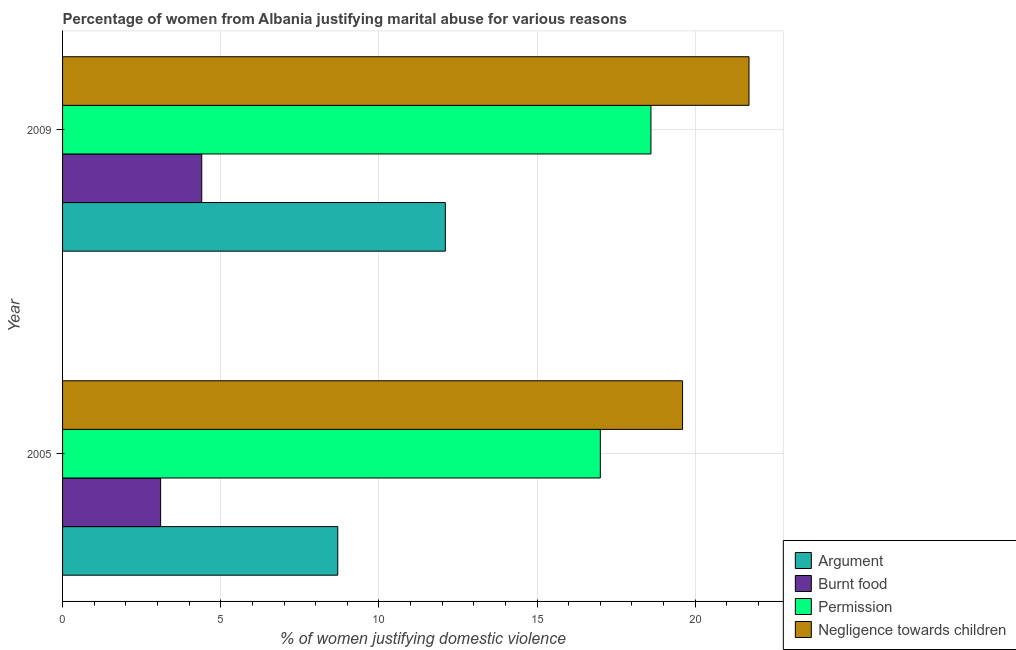How many groups of bars are there?
Provide a succinct answer. 2. How many bars are there on the 1st tick from the bottom?
Make the answer very short. 4. What is the label of the 2nd group of bars from the top?
Your response must be concise. 2005. In how many cases, is the number of bars for a given year not equal to the number of legend labels?
Offer a terse response. 0. What is the percentage of women justifying abuse for burning food in 2005?
Ensure brevity in your answer.  3.1. In which year was the percentage of women justifying abuse for showing negligence towards children maximum?
Your answer should be compact. 2009. In which year was the percentage of women justifying abuse for going without permission minimum?
Your answer should be compact. 2005. What is the total percentage of women justifying abuse for going without permission in the graph?
Ensure brevity in your answer.  35.6. What is the difference between the percentage of women justifying abuse for burning food in 2009 and the percentage of women justifying abuse in the case of an argument in 2005?
Your answer should be compact. -4.3. What is the average percentage of women justifying abuse for burning food per year?
Your answer should be compact. 3.75. In the year 2005, what is the difference between the percentage of women justifying abuse for burning food and percentage of women justifying abuse for showing negligence towards children?
Ensure brevity in your answer.  -16.5. In how many years, is the percentage of women justifying abuse for going without permission greater than 14 %?
Your answer should be very brief. 2. What is the ratio of the percentage of women justifying abuse for showing negligence towards children in 2005 to that in 2009?
Provide a short and direct response. 0.9. Is the percentage of women justifying abuse for showing negligence towards children in 2005 less than that in 2009?
Ensure brevity in your answer.  Yes. Is the difference between the percentage of women justifying abuse for burning food in 2005 and 2009 greater than the difference between the percentage of women justifying abuse for going without permission in 2005 and 2009?
Provide a short and direct response. Yes. In how many years, is the percentage of women justifying abuse in the case of an argument greater than the average percentage of women justifying abuse in the case of an argument taken over all years?
Ensure brevity in your answer.  1. What does the 1st bar from the top in 2005 represents?
Offer a very short reply. Negligence towards children. What does the 2nd bar from the bottom in 2005 represents?
Your answer should be very brief. Burnt food. Is it the case that in every year, the sum of the percentage of women justifying abuse in the case of an argument and percentage of women justifying abuse for burning food is greater than the percentage of women justifying abuse for going without permission?
Make the answer very short. No. Does the graph contain any zero values?
Ensure brevity in your answer.  No. Does the graph contain grids?
Provide a succinct answer. Yes. Where does the legend appear in the graph?
Ensure brevity in your answer.  Bottom right. How many legend labels are there?
Make the answer very short. 4. How are the legend labels stacked?
Your response must be concise. Vertical. What is the title of the graph?
Your answer should be very brief. Percentage of women from Albania justifying marital abuse for various reasons. Does "HFC gas" appear as one of the legend labels in the graph?
Provide a short and direct response. No. What is the label or title of the X-axis?
Offer a terse response. % of women justifying domestic violence. What is the label or title of the Y-axis?
Offer a terse response. Year. What is the % of women justifying domestic violence in Argument in 2005?
Keep it short and to the point. 8.7. What is the % of women justifying domestic violence in Burnt food in 2005?
Your answer should be compact. 3.1. What is the % of women justifying domestic violence of Negligence towards children in 2005?
Make the answer very short. 19.6. What is the % of women justifying domestic violence in Permission in 2009?
Offer a very short reply. 18.6. What is the % of women justifying domestic violence of Negligence towards children in 2009?
Ensure brevity in your answer.  21.7. Across all years, what is the maximum % of women justifying domestic violence of Burnt food?
Offer a terse response. 4.4. Across all years, what is the maximum % of women justifying domestic violence in Permission?
Keep it short and to the point. 18.6. Across all years, what is the maximum % of women justifying domestic violence of Negligence towards children?
Your response must be concise. 21.7. Across all years, what is the minimum % of women justifying domestic violence of Negligence towards children?
Make the answer very short. 19.6. What is the total % of women justifying domestic violence of Argument in the graph?
Keep it short and to the point. 20.8. What is the total % of women justifying domestic violence of Burnt food in the graph?
Provide a succinct answer. 7.5. What is the total % of women justifying domestic violence in Permission in the graph?
Give a very brief answer. 35.6. What is the total % of women justifying domestic violence of Negligence towards children in the graph?
Make the answer very short. 41.3. What is the difference between the % of women justifying domestic violence in Permission in 2005 and that in 2009?
Your response must be concise. -1.6. What is the difference between the % of women justifying domestic violence of Negligence towards children in 2005 and that in 2009?
Give a very brief answer. -2.1. What is the difference between the % of women justifying domestic violence in Argument in 2005 and the % of women justifying domestic violence in Burnt food in 2009?
Ensure brevity in your answer.  4.3. What is the difference between the % of women justifying domestic violence of Argument in 2005 and the % of women justifying domestic violence of Permission in 2009?
Provide a short and direct response. -9.9. What is the difference between the % of women justifying domestic violence of Burnt food in 2005 and the % of women justifying domestic violence of Permission in 2009?
Give a very brief answer. -15.5. What is the difference between the % of women justifying domestic violence of Burnt food in 2005 and the % of women justifying domestic violence of Negligence towards children in 2009?
Your answer should be very brief. -18.6. What is the difference between the % of women justifying domestic violence in Permission in 2005 and the % of women justifying domestic violence in Negligence towards children in 2009?
Offer a terse response. -4.7. What is the average % of women justifying domestic violence of Argument per year?
Provide a short and direct response. 10.4. What is the average % of women justifying domestic violence of Burnt food per year?
Offer a very short reply. 3.75. What is the average % of women justifying domestic violence in Negligence towards children per year?
Your answer should be compact. 20.65. In the year 2005, what is the difference between the % of women justifying domestic violence in Argument and % of women justifying domestic violence in Burnt food?
Make the answer very short. 5.6. In the year 2005, what is the difference between the % of women justifying domestic violence of Burnt food and % of women justifying domestic violence of Permission?
Ensure brevity in your answer.  -13.9. In the year 2005, what is the difference between the % of women justifying domestic violence in Burnt food and % of women justifying domestic violence in Negligence towards children?
Offer a very short reply. -16.5. In the year 2009, what is the difference between the % of women justifying domestic violence in Burnt food and % of women justifying domestic violence in Negligence towards children?
Give a very brief answer. -17.3. In the year 2009, what is the difference between the % of women justifying domestic violence of Permission and % of women justifying domestic violence of Negligence towards children?
Provide a succinct answer. -3.1. What is the ratio of the % of women justifying domestic violence of Argument in 2005 to that in 2009?
Your response must be concise. 0.72. What is the ratio of the % of women justifying domestic violence of Burnt food in 2005 to that in 2009?
Ensure brevity in your answer.  0.7. What is the ratio of the % of women justifying domestic violence of Permission in 2005 to that in 2009?
Your response must be concise. 0.91. What is the ratio of the % of women justifying domestic violence of Negligence towards children in 2005 to that in 2009?
Offer a terse response. 0.9. What is the difference between the highest and the second highest % of women justifying domestic violence of Argument?
Ensure brevity in your answer.  3.4. What is the difference between the highest and the second highest % of women justifying domestic violence in Burnt food?
Your response must be concise. 1.3. What is the difference between the highest and the second highest % of women justifying domestic violence of Negligence towards children?
Your answer should be compact. 2.1. What is the difference between the highest and the lowest % of women justifying domestic violence of Argument?
Your answer should be compact. 3.4. What is the difference between the highest and the lowest % of women justifying domestic violence in Burnt food?
Your answer should be compact. 1.3. What is the difference between the highest and the lowest % of women justifying domestic violence in Permission?
Make the answer very short. 1.6. What is the difference between the highest and the lowest % of women justifying domestic violence in Negligence towards children?
Provide a short and direct response. 2.1. 